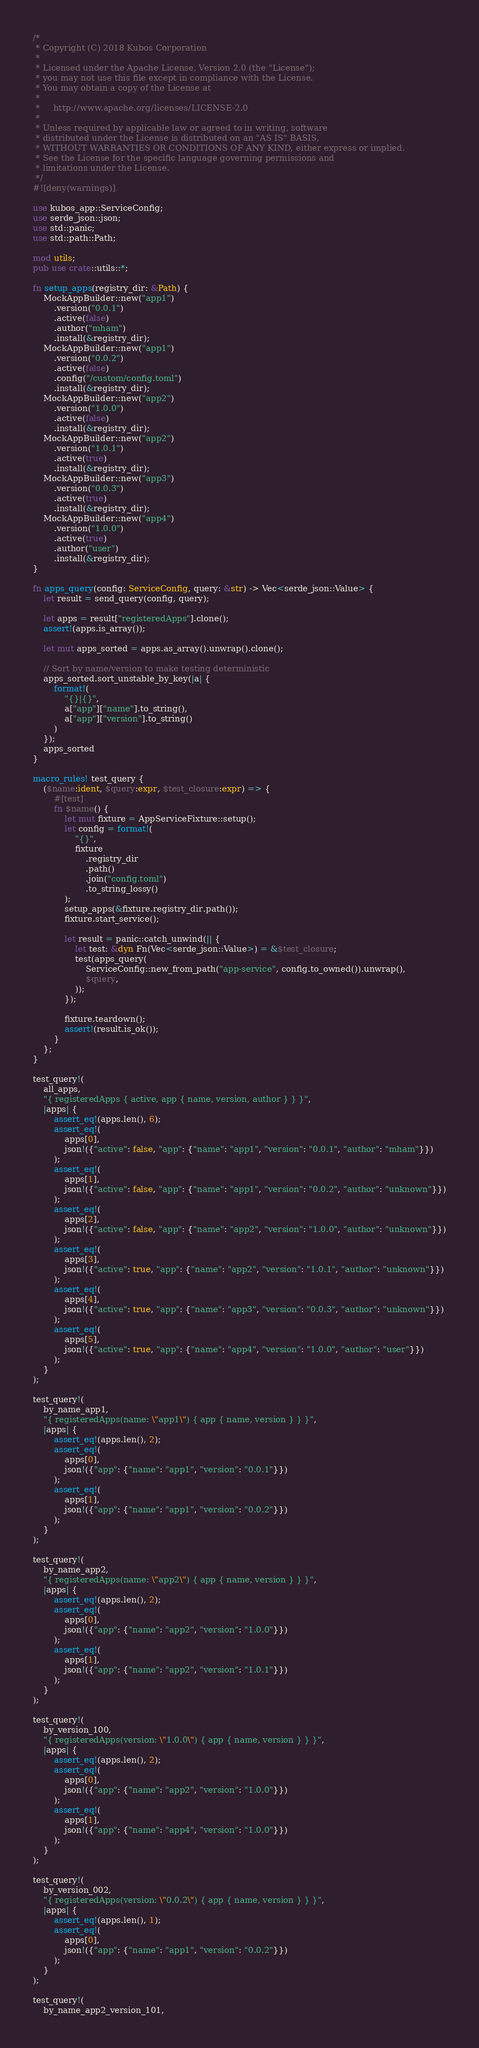<code> <loc_0><loc_0><loc_500><loc_500><_Rust_>/*
 * Copyright (C) 2018 Kubos Corporation
 *
 * Licensed under the Apache License, Version 2.0 (the "License");
 * you may not use this file except in compliance with the License.
 * You may obtain a copy of the License at
 *
 *     http://www.apache.org/licenses/LICENSE-2.0
 *
 * Unless required by applicable law or agreed to in writing, software
 * distributed under the License is distributed on an "AS IS" BASIS,
 * WITHOUT WARRANTIES OR CONDITIONS OF ANY KIND, either express or implied.
 * See the License for the specific language governing permissions and
 * limitations under the License.
 */
#![deny(warnings)]

use kubos_app::ServiceConfig;
use serde_json::json;
use std::panic;
use std::path::Path;

mod utils;
pub use crate::utils::*;

fn setup_apps(registry_dir: &Path) {
    MockAppBuilder::new("app1")
        .version("0.0.1")
        .active(false)
        .author("mham")
        .install(&registry_dir);
    MockAppBuilder::new("app1")
        .version("0.0.2")
        .active(false)
        .config("/custom/config.toml")
        .install(&registry_dir);
    MockAppBuilder::new("app2")
        .version("1.0.0")
        .active(false)
        .install(&registry_dir);
    MockAppBuilder::new("app2")
        .version("1.0.1")
        .active(true)
        .install(&registry_dir);
    MockAppBuilder::new("app3")
        .version("0.0.3")
        .active(true)
        .install(&registry_dir);
    MockAppBuilder::new("app4")
        .version("1.0.0")
        .active(true)
        .author("user")
        .install(&registry_dir);
}

fn apps_query(config: ServiceConfig, query: &str) -> Vec<serde_json::Value> {
    let result = send_query(config, query);

    let apps = result["registeredApps"].clone();
    assert!(apps.is_array());

    let mut apps_sorted = apps.as_array().unwrap().clone();

    // Sort by name/version to make testing deterministic
    apps_sorted.sort_unstable_by_key(|a| {
        format!(
            "{}|{}",
            a["app"]["name"].to_string(),
            a["app"]["version"].to_string()
        )
    });
    apps_sorted
}

macro_rules! test_query {
    ($name:ident, $query:expr, $test_closure:expr) => {
        #[test]
        fn $name() {
            let mut fixture = AppServiceFixture::setup();
            let config = format!(
                "{}",
                fixture
                    .registry_dir
                    .path()
                    .join("config.toml")
                    .to_string_lossy()
            );
            setup_apps(&fixture.registry_dir.path());
            fixture.start_service();

            let result = panic::catch_unwind(|| {
                let test: &dyn Fn(Vec<serde_json::Value>) = &$test_closure;
                test(apps_query(
                    ServiceConfig::new_from_path("app-service", config.to_owned()).unwrap(),
                    $query,
                ));
            });

            fixture.teardown();
            assert!(result.is_ok());
        }
    };
}

test_query!(
    all_apps,
    "{ registeredApps { active, app { name, version, author } } }",
    |apps| {
        assert_eq!(apps.len(), 6);
        assert_eq!(
            apps[0],
            json!({"active": false, "app": {"name": "app1", "version": "0.0.1", "author": "mham"}})
        );
        assert_eq!(
            apps[1],
            json!({"active": false, "app": {"name": "app1", "version": "0.0.2", "author": "unknown"}})
        );
        assert_eq!(
            apps[2],
            json!({"active": false, "app": {"name": "app2", "version": "1.0.0", "author": "unknown"}})
        );
        assert_eq!(
            apps[3],
            json!({"active": true, "app": {"name": "app2", "version": "1.0.1", "author": "unknown"}})
        );
        assert_eq!(
            apps[4],
            json!({"active": true, "app": {"name": "app3", "version": "0.0.3", "author": "unknown"}})
        );
        assert_eq!(
            apps[5],
            json!({"active": true, "app": {"name": "app4", "version": "1.0.0", "author": "user"}})
        );
    }
);

test_query!(
    by_name_app1,
    "{ registeredApps(name: \"app1\") { app { name, version } } }",
    |apps| {
        assert_eq!(apps.len(), 2);
        assert_eq!(
            apps[0],
            json!({"app": {"name": "app1", "version": "0.0.1"}})
        );
        assert_eq!(
            apps[1],
            json!({"app": {"name": "app1", "version": "0.0.2"}})
        );
    }
);

test_query!(
    by_name_app2,
    "{ registeredApps(name: \"app2\") { app { name, version } } }",
    |apps| {
        assert_eq!(apps.len(), 2);
        assert_eq!(
            apps[0],
            json!({"app": {"name": "app2", "version": "1.0.0"}})
        );
        assert_eq!(
            apps[1],
            json!({"app": {"name": "app2", "version": "1.0.1"}})
        );
    }
);

test_query!(
    by_version_100,
    "{ registeredApps(version: \"1.0.0\") { app { name, version } } }",
    |apps| {
        assert_eq!(apps.len(), 2);
        assert_eq!(
            apps[0],
            json!({"app": {"name": "app2", "version": "1.0.0"}})
        );
        assert_eq!(
            apps[1],
            json!({"app": {"name": "app4", "version": "1.0.0"}})
        );
    }
);

test_query!(
    by_version_002,
    "{ registeredApps(version: \"0.0.2\") { app { name, version } } }",
    |apps| {
        assert_eq!(apps.len(), 1);
        assert_eq!(
            apps[0],
            json!({"app": {"name": "app1", "version": "0.0.2"}})
        );
    }
);

test_query!(
    by_name_app2_version_101,</code> 